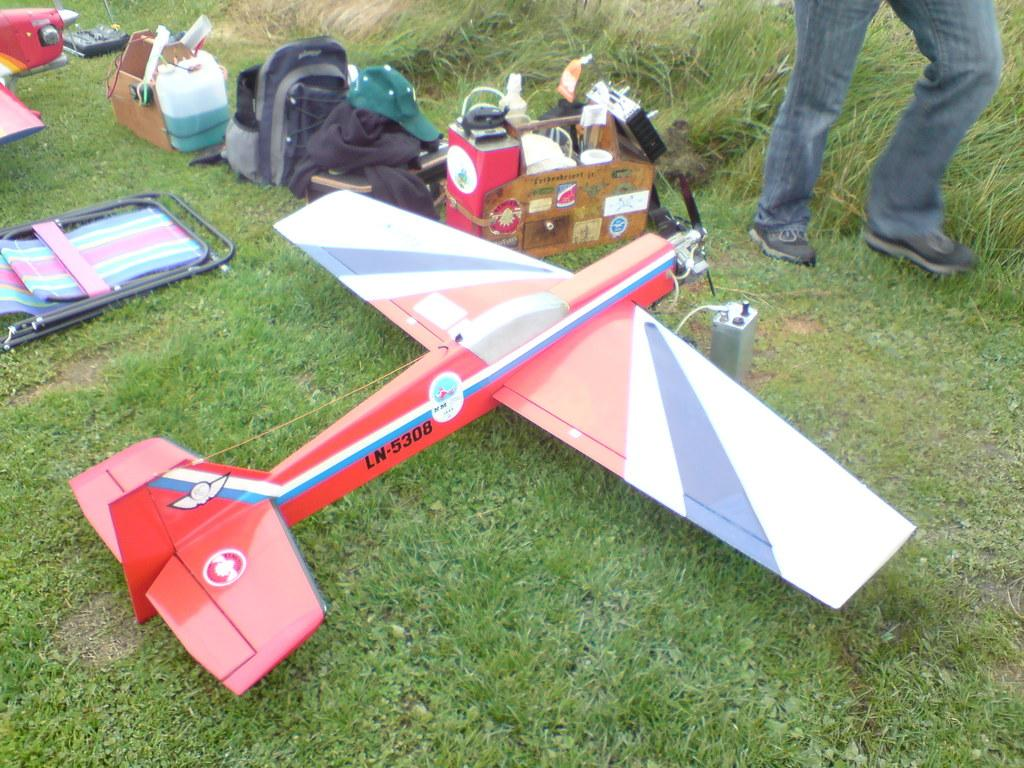<image>
Offer a succinct explanation of the picture presented. A model airplane on grass with the letter and numbers LN-5308 on the side of it. 